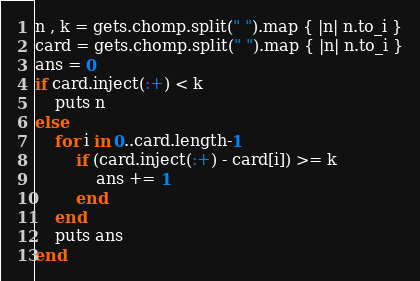<code> <loc_0><loc_0><loc_500><loc_500><_Ruby_>n , k = gets.chomp.split(" ").map { |n| n.to_i }
card = gets.chomp.split(" ").map { |n| n.to_i }
ans = 0
if card.inject(:+) < k
	puts n
else
	for i in 0..card.length-1
		if (card.inject(:+) - card[i]) >= k
			ans += 1
		end
	end
	puts ans
end
</code> 